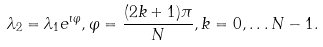<formula> <loc_0><loc_0><loc_500><loc_500>\lambda _ { 2 } = \lambda _ { 1 } e ^ { \imath \varphi } , \varphi = \frac { ( 2 k + 1 ) \pi } { N } , k = 0 , \dots N - 1 .</formula> 